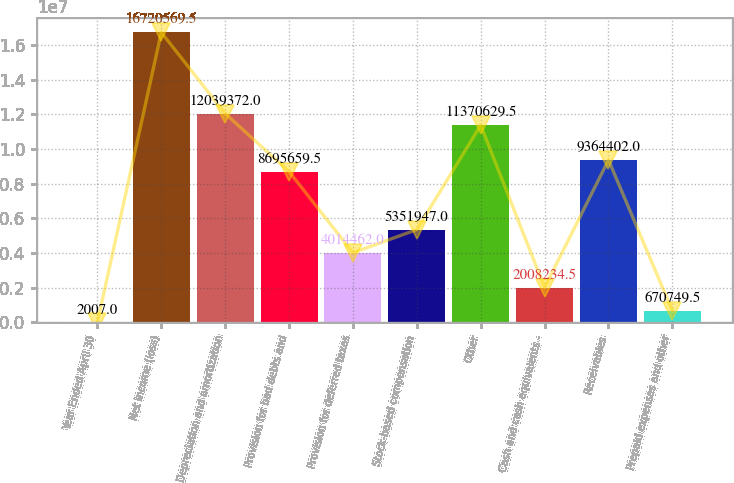<chart> <loc_0><loc_0><loc_500><loc_500><bar_chart><fcel>Year Ended April 30<fcel>Net income (loss)<fcel>Depreciation and amortization<fcel>Provision for bad debts and<fcel>Provision for deferred taxes<fcel>Stock-based compensation<fcel>Other<fcel>Cash and cash equivalents -<fcel>Receivables<fcel>Prepaid expenses and other<nl><fcel>2007<fcel>1.67206e+07<fcel>1.20394e+07<fcel>8.69566e+06<fcel>4.01446e+06<fcel>5.35195e+06<fcel>1.13706e+07<fcel>2.00823e+06<fcel>9.3644e+06<fcel>670750<nl></chart> 